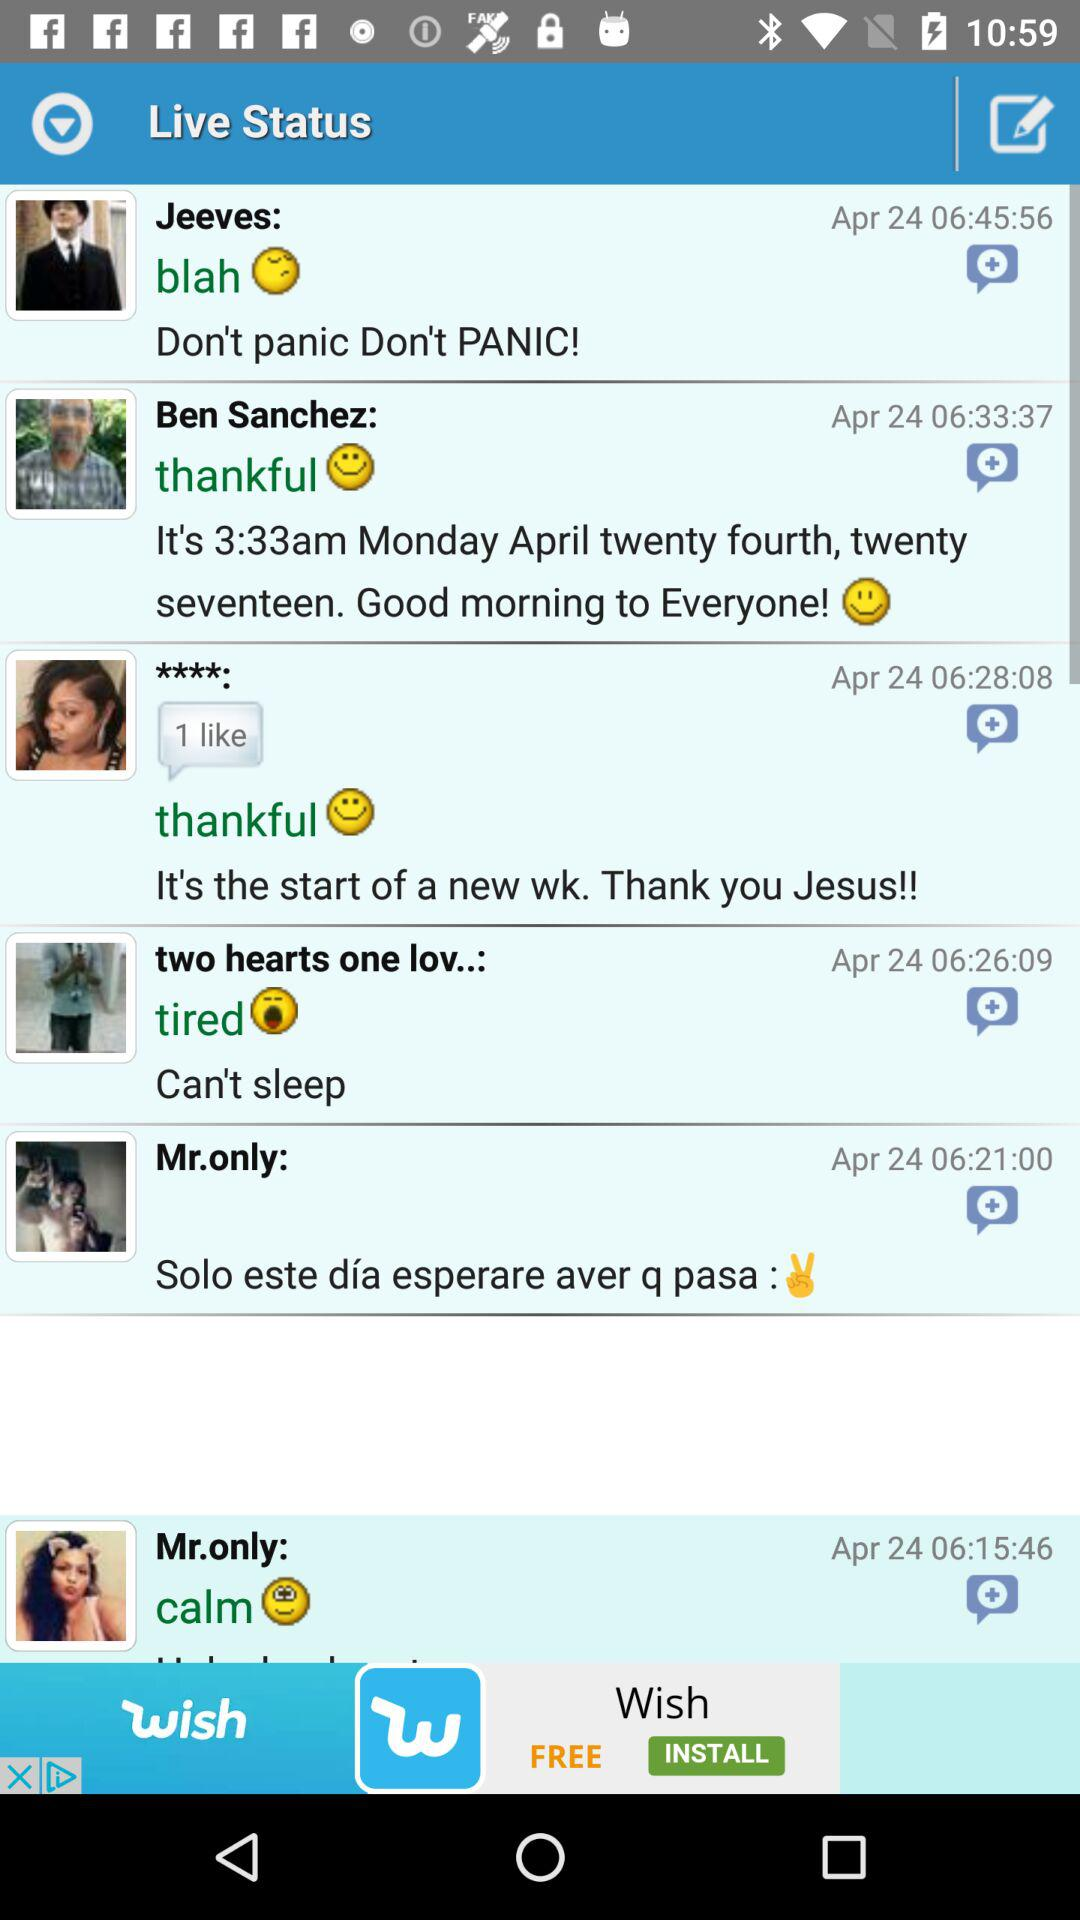What is the mentioned status? The mentioned status is "Live". 